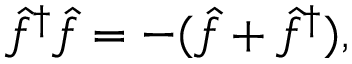<formula> <loc_0><loc_0><loc_500><loc_500>\hat { f } ^ { \dagger } \hat { f } = - ( \hat { f } + \hat { f } ^ { \dagger } ) ,</formula> 